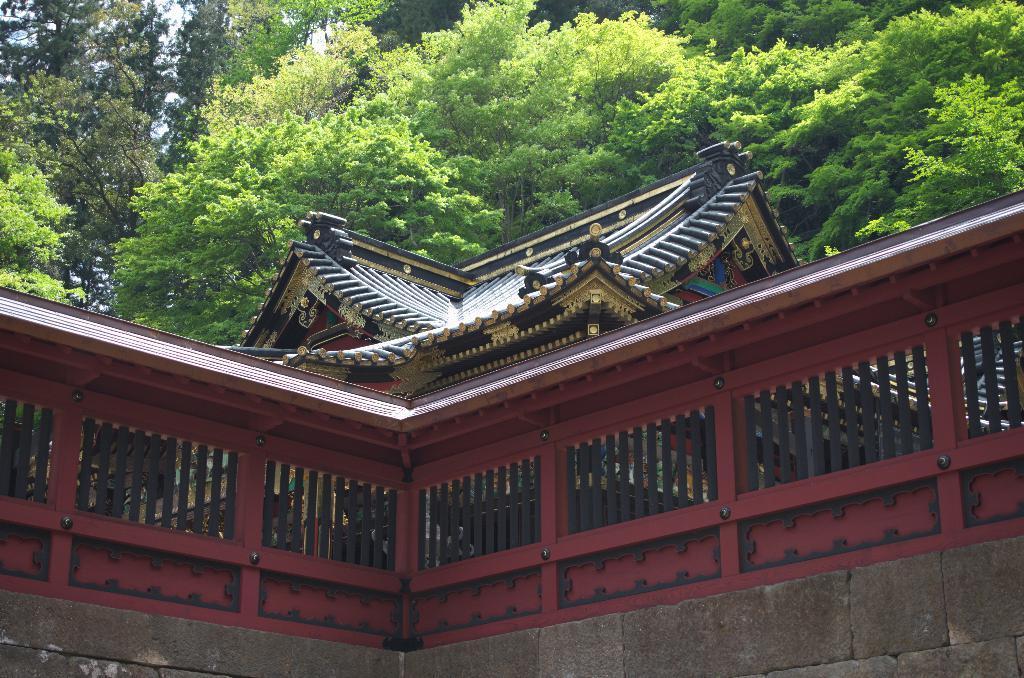In one or two sentences, can you explain what this image depicts? In this image we can see a building, grill and trees. 